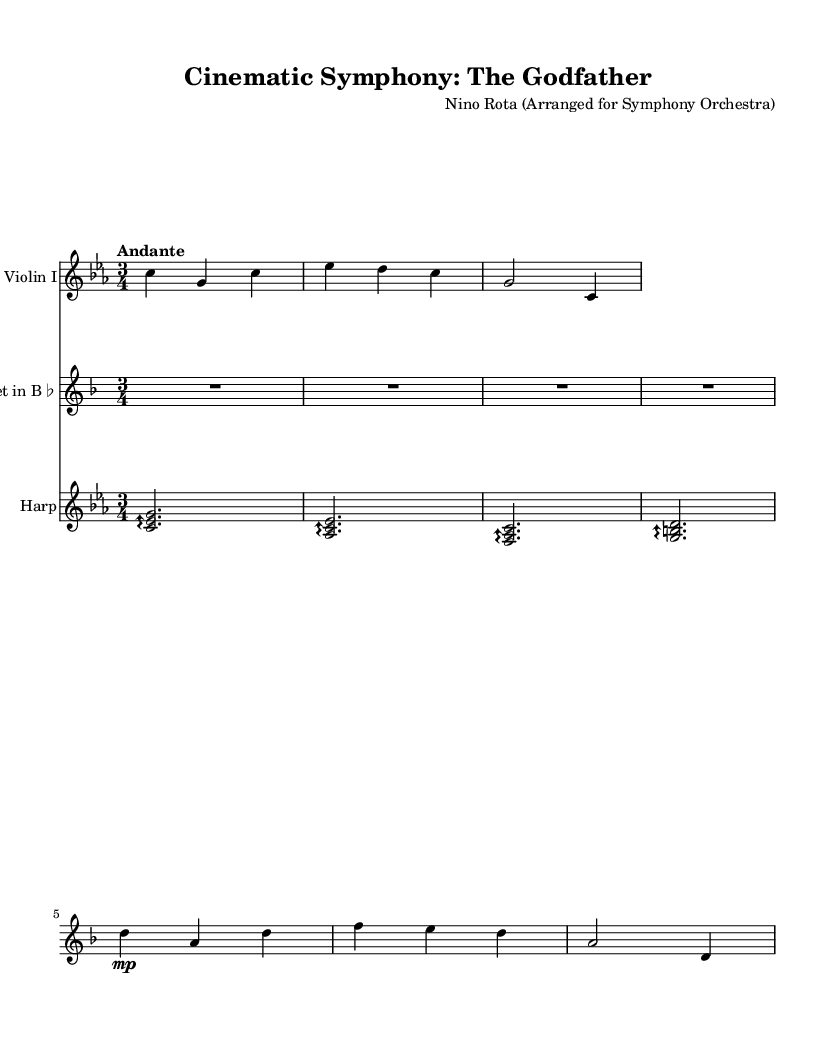What is the key signature of this music? The key signature is C minor, indicated by the two flats in the key signature.
Answer: C minor What is the time signature of this piece? The time signature is 3/4, shown at the beginning of the music as a fraction.
Answer: 3/4 What is the tempo marking of the piece? The tempo marking is "Andante," indicating a moderate pace, which can be found at the beginning of the score.
Answer: Andante How many measures are in the violin part? There are six measures in the violin part, as counted from the beginning to the end of the provided notes.
Answer: 6 What is the first note played by the trumpet? The first note played by the trumpet is C, which is the first note written in the trumpet staff.
Answer: C What is the highest note in the harp part? The highest note in the harp part is G, indicated as the highest pitch in the given arpeggios.
Answer: G What type of musical ensemble is this arrangement for? The arrangement is for a symphony orchestra, which includes strings, brass, and harp.
Answer: Symphony orchestra 